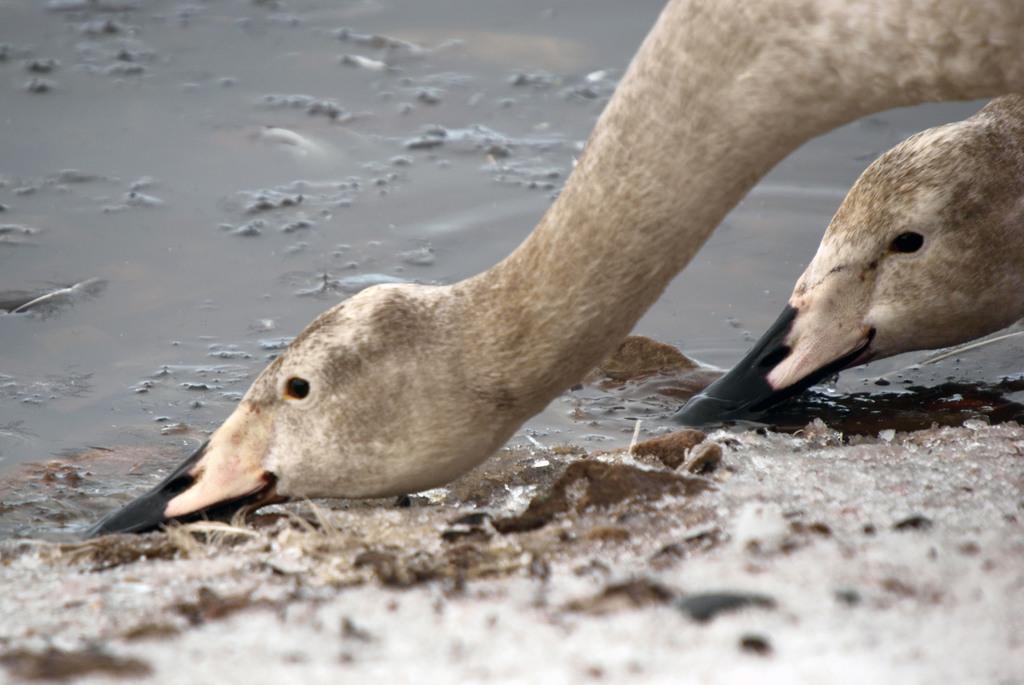Can you describe this image briefly? In this picture there are two ducks in the image and there is water in the image. 